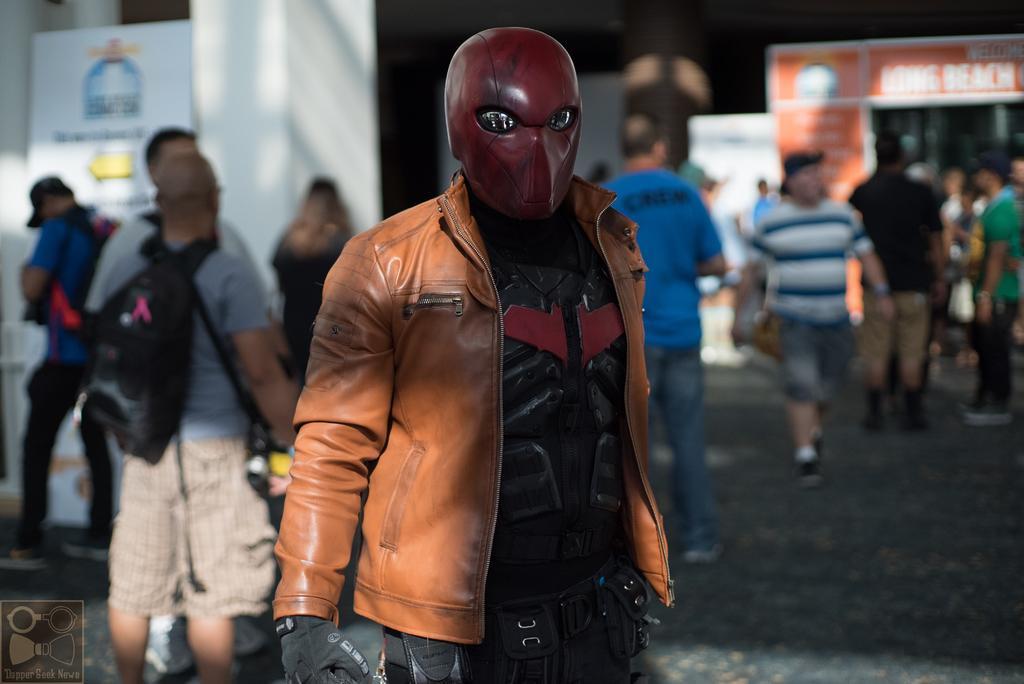Describe this image in one or two sentences. In the picture we can see a person standing and with a costume and in the background we can see some people are standing and talking to each other and some are walking and behind them we can see some pillar and some boards with some advertisements on it. 